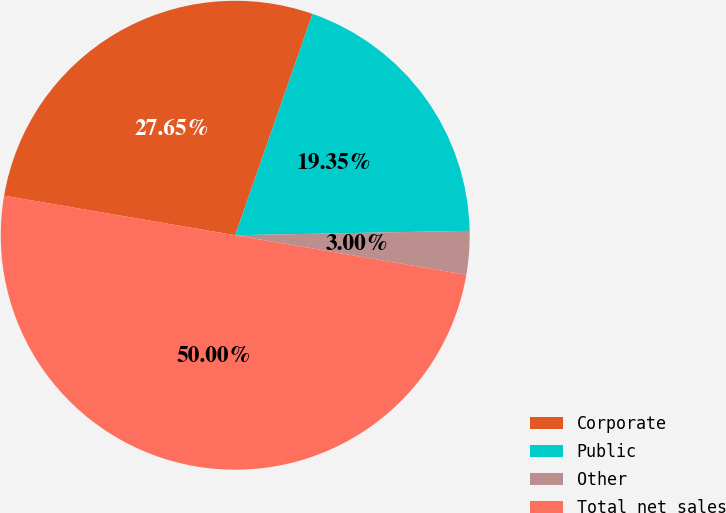<chart> <loc_0><loc_0><loc_500><loc_500><pie_chart><fcel>Corporate<fcel>Public<fcel>Other<fcel>Total net sales<nl><fcel>27.65%<fcel>19.35%<fcel>3.0%<fcel>50.0%<nl></chart> 